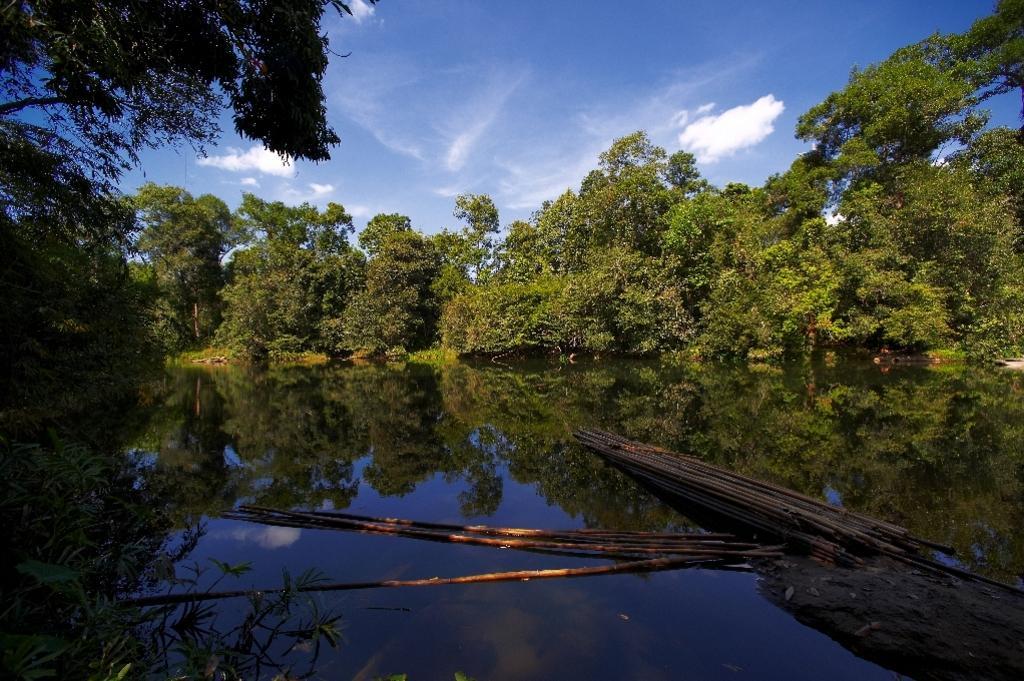Please provide a concise description of this image. In the center of the image there is water and we can see stocks on the water. In the background there are trees and sky. 